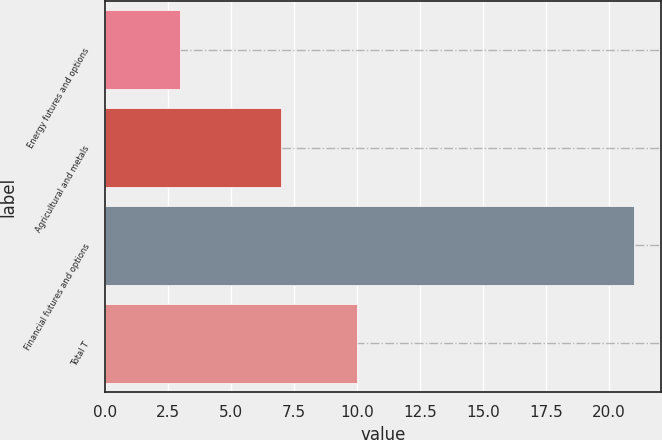<chart> <loc_0><loc_0><loc_500><loc_500><bar_chart><fcel>Energy futures and options<fcel>Agricultural and metals<fcel>Financial futures and options<fcel>Total T<nl><fcel>3<fcel>7<fcel>21<fcel>10<nl></chart> 